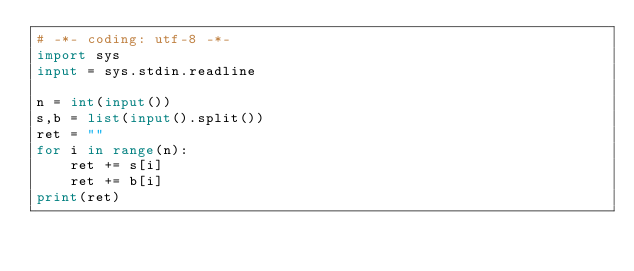<code> <loc_0><loc_0><loc_500><loc_500><_Python_># -*- coding: utf-8 -*-
import sys
input = sys.stdin.readline

n = int(input())
s,b = list(input().split())
ret = ""
for i in range(n):
    ret += s[i]
    ret += b[i]
print(ret)</code> 